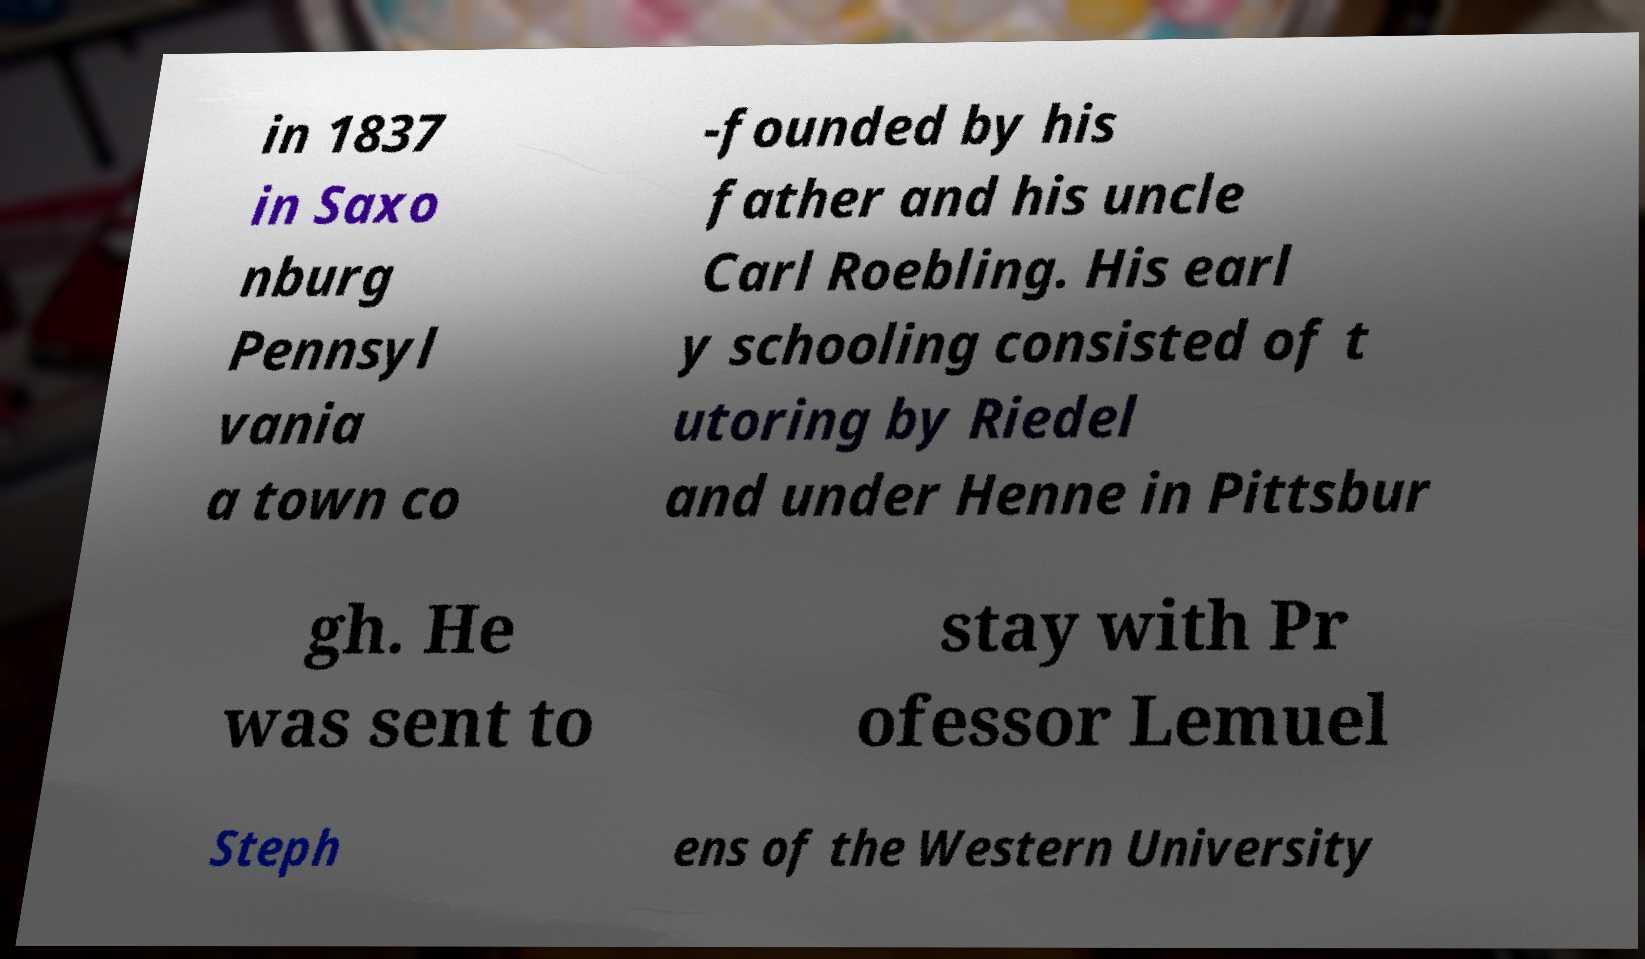What messages or text are displayed in this image? I need them in a readable, typed format. in 1837 in Saxo nburg Pennsyl vania a town co -founded by his father and his uncle Carl Roebling. His earl y schooling consisted of t utoring by Riedel and under Henne in Pittsbur gh. He was sent to stay with Pr ofessor Lemuel Steph ens of the Western University 